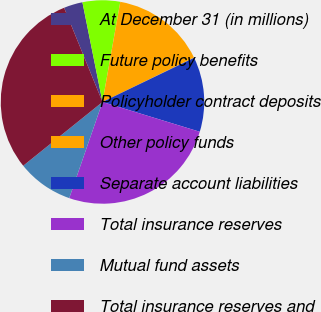<chart> <loc_0><loc_0><loc_500><loc_500><pie_chart><fcel>At December 31 (in millions)<fcel>Future policy benefits<fcel>Policyholder contract deposits<fcel>Other policy funds<fcel>Separate account liabilities<fcel>Total insurance reserves<fcel>Mutual fund assets<fcel>Total insurance reserves and<nl><fcel>3.0%<fcel>5.96%<fcel>15.0%<fcel>0.05%<fcel>11.88%<fcel>25.57%<fcel>8.92%<fcel>29.62%<nl></chart> 